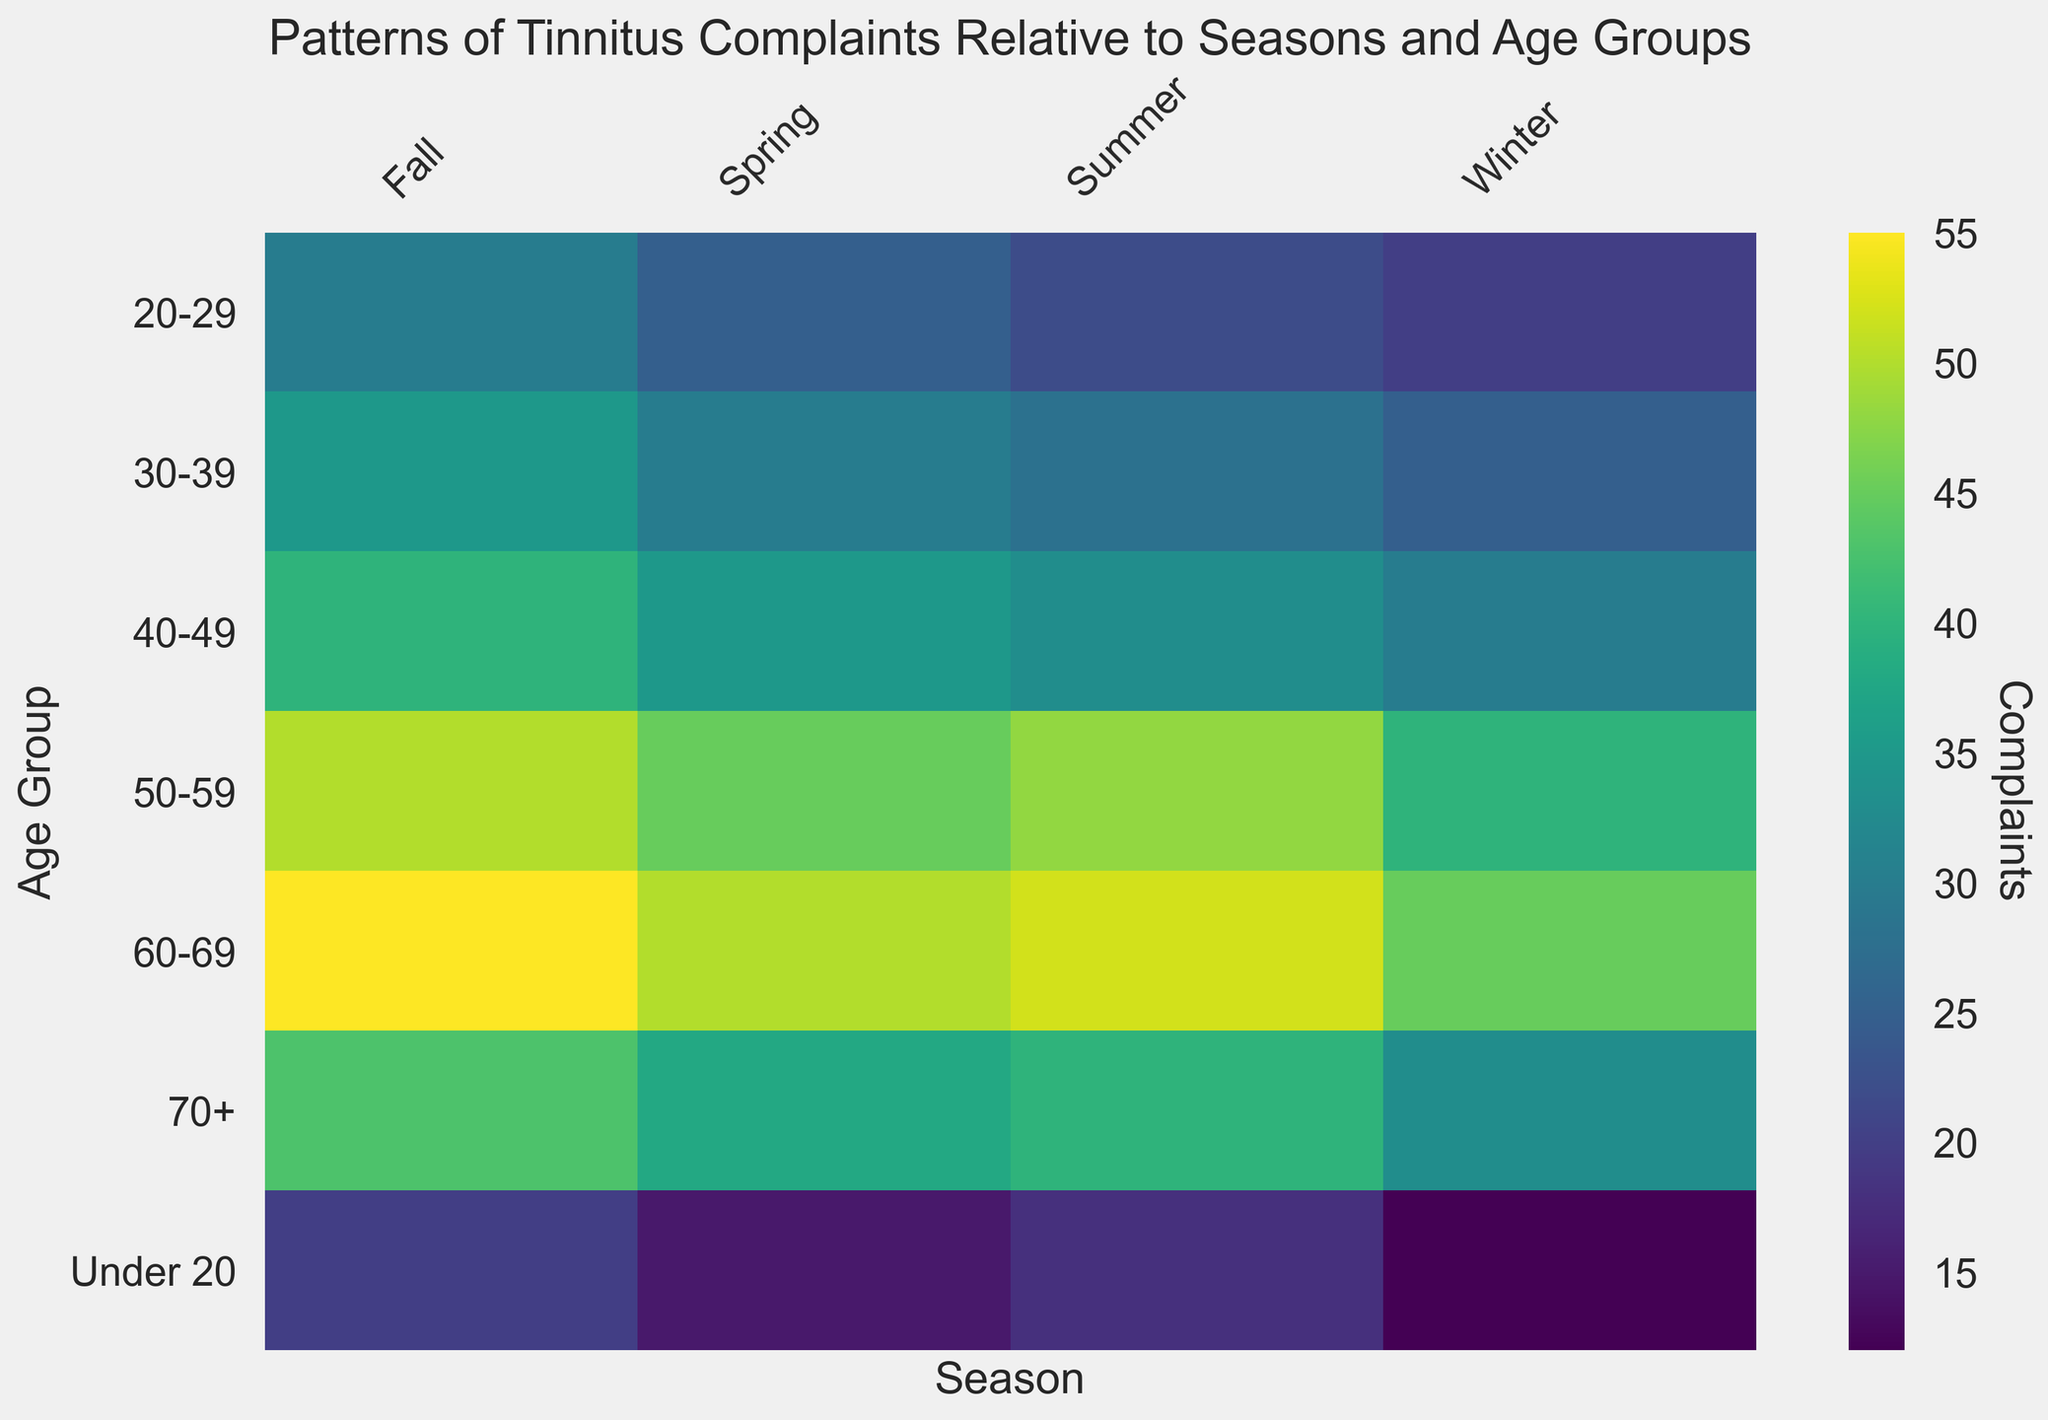What season and age group show the highest number of tinnitus complaints? To find the highest number of complaints, look at the entire heatmap and identify the cell with the darkest color, which corresponds to the highest value. The highest value is 55 complaints in the Fall season for the 60-69 age group.
Answer: Fall, 60-69 How do the tinnitus complaints of the 30-39 age group compare between Winter and Spring? To compare, look at the 30-39 age group row and find the cells under Winter and Spring columns. The values are 25 (Winter) and 30 (Spring). Spring has more complaints than Winter by a difference of 5.
Answer: Spring has 5 more complaints than Winter What is the average number of tinnitus complaints for the 50-59 age group across all seasons? Calculate the average by summing the number of complaints for the 50-59 age group in all seasons (40 + 45 + 48 + 50) and dividing by 4. The total is 183, so the average is 183/4 = 45.75.
Answer: 45.75 Which age group shows the lowest number of tinnitus complaints in Summer? Look at the column for Summer and identify the cell with the lightest color corresponding to the smallest value. The value is 18 complaints for the Under 20 age group.
Answer: Under 20 What's the total number of tinnitus complaints for the 70+ age group across all seasons? Sum the number of complaints for the 70+ age group across Winter, Spring, Summer, and Fall (33 + 38 + 40 + 43). The total is 154.
Answer: 154 In which season do the 20-29 and 40-49 age groups have the same number of complaints? Look at the rows for the 20-29 and 40-49 age groups and compare their values across all seasons. In the Summer, both age groups have 22 and 33 complaints, respectively (not equal). Fall shows 30 and 40 (not equal), Winter shows 20 and 30 (not equal). In Spring, the values are 25 and 35. No season has equal complaints.
Answer: No season What is the difference in tinnitus complaints between the Under 20 and 60-69 age groups during Fall? Look at the cells for Under 20 and 60-69 age groups in the Fall column. The values are 20 and 55, respectively. The difference is 55 - 20 = 35.
Answer: 35 How does the number of tinnitus complaints change from Winter to Fall for the 50-59 age group? Look at the values for the 50-59 age group in Winter and Fall. The numbers are 40 and 50, respectively. The complaints increase by 10 from Winter to Fall.
Answer: Increase by 10 